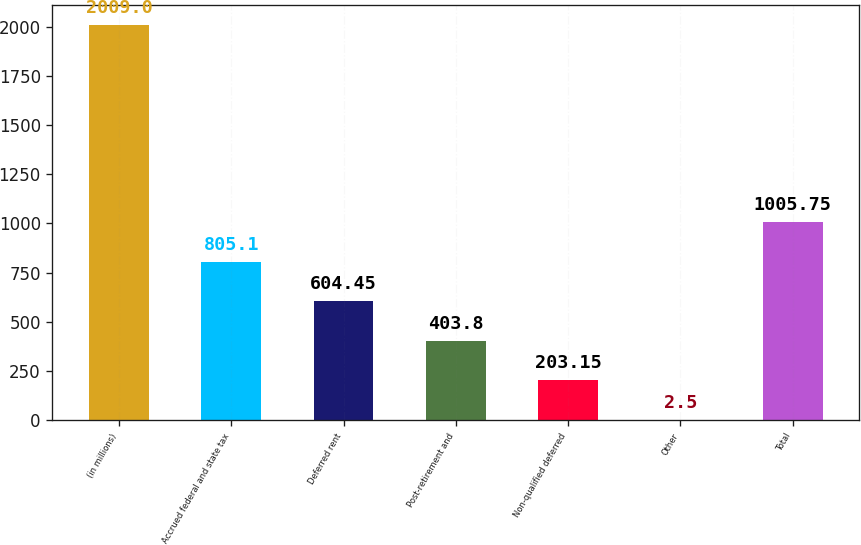Convert chart to OTSL. <chart><loc_0><loc_0><loc_500><loc_500><bar_chart><fcel>(in millions)<fcel>Accrued federal and state tax<fcel>Deferred rent<fcel>Post-retirement and<fcel>Non-qualified deferred<fcel>Other<fcel>Total<nl><fcel>2009<fcel>805.1<fcel>604.45<fcel>403.8<fcel>203.15<fcel>2.5<fcel>1005.75<nl></chart> 